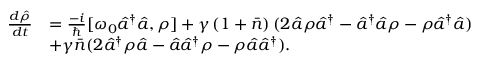Convert formula to latex. <formula><loc_0><loc_0><loc_500><loc_500>\begin{array} { r l } { \frac { d \hat { \rho } } { d t } } & { = \frac { - i } { } [ \omega _ { 0 } \hat { a } ^ { \dagger } \hat { a } , \rho ] + \gamma \left ( 1 + \bar { n } \right ) ( 2 \hat { a } \rho \hat { a } ^ { \dagger } - \hat { a } ^ { \dagger } \hat { a } \rho - \rho \hat { a } ^ { \dagger } \hat { a } ) } \\ & { + \gamma \bar { n } ( 2 \hat { a } ^ { \dagger } \rho \hat { a } - \hat { a } \hat { a } ^ { \dagger } \rho - \rho \hat { a } \hat { a } ^ { \dagger } ) . } \end{array}</formula> 